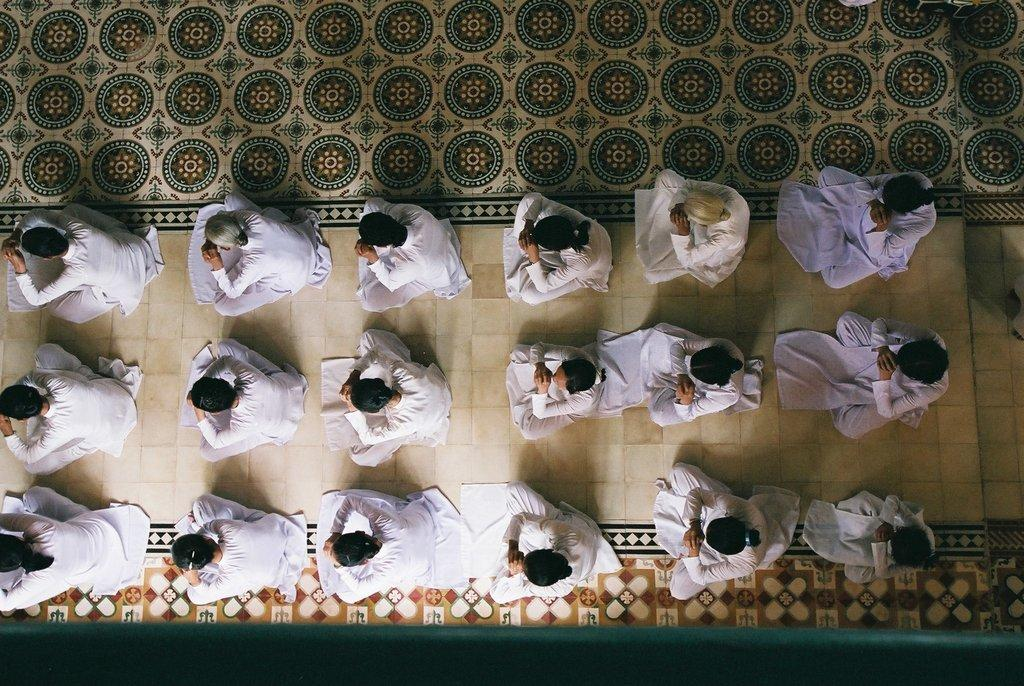Who or what is present in the image? There are people in the image. What are the people wearing? The people are wearing white dresses. Are there any deer visible in the image? No, there are no deer present in the image. What type of butter is being used by the women in the image? There are no women or butter present in the image. What type of butter is being used by the women in the image? There are no women or butter present in the image. 